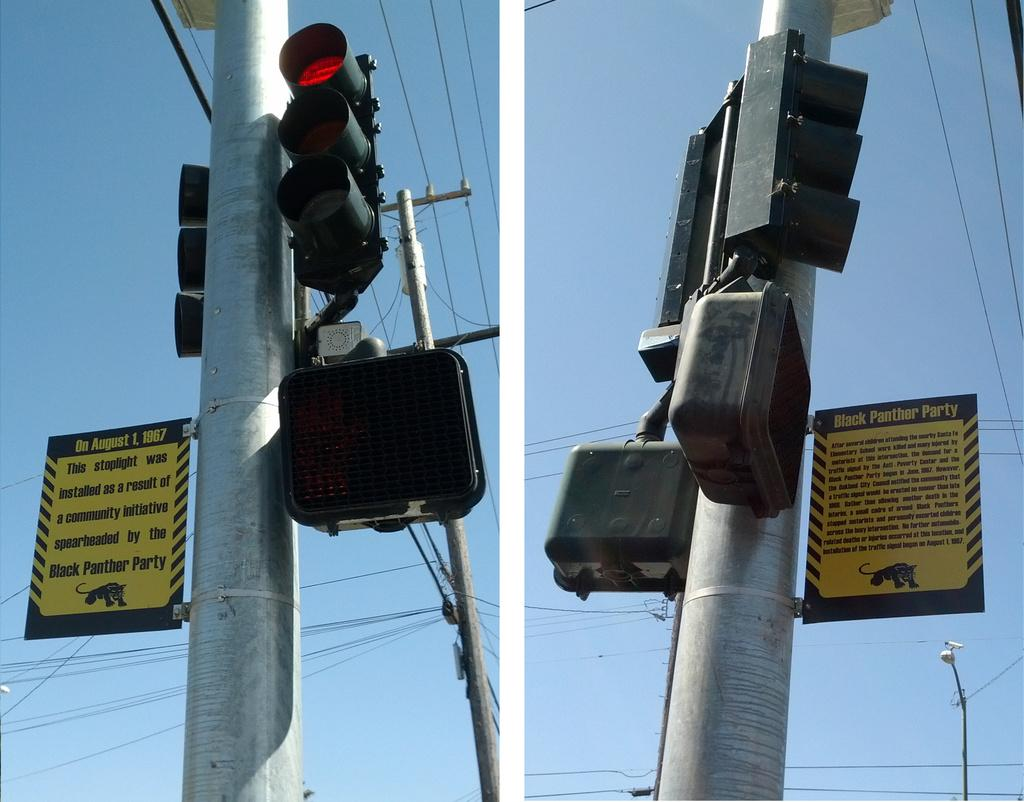<image>
Present a compact description of the photo's key features. A traffic light has a yellow sign next to it explaining what the Black Panthers had to do with it being there. 